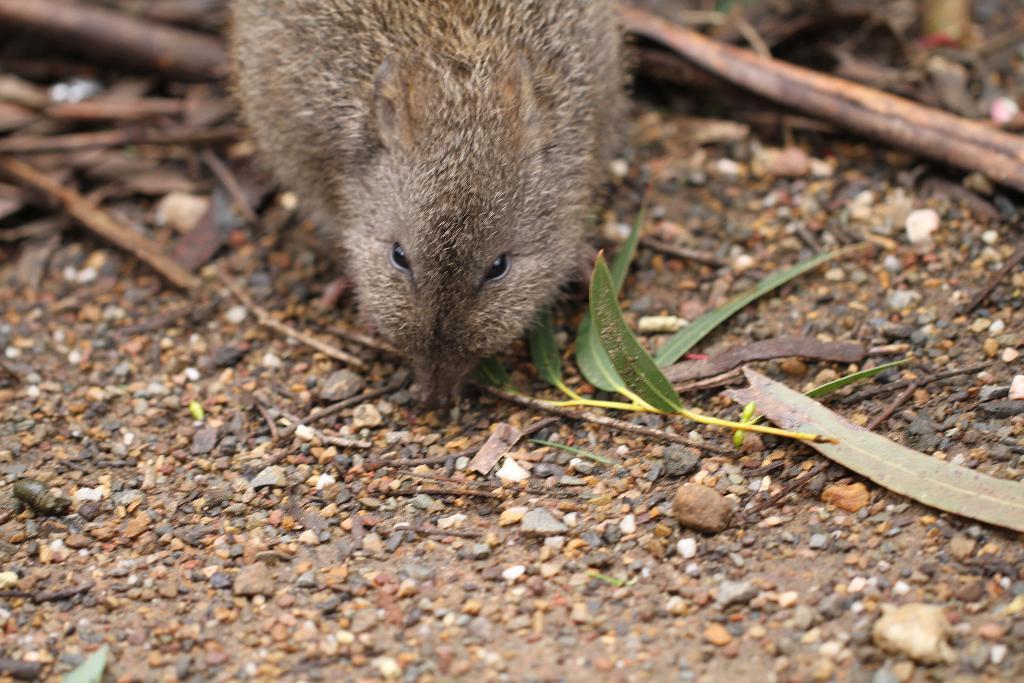Can you describe this image briefly? Here I can see a rat on the ground. Beside the rat I can see few sticks, leaves and stones. 